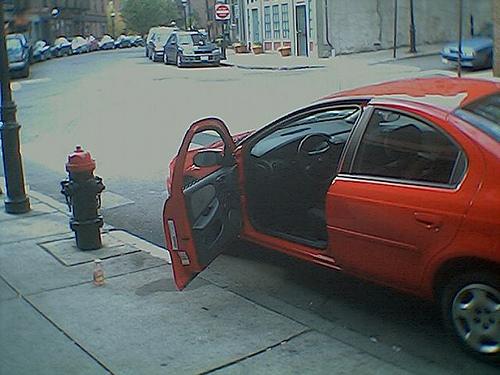Is one of the car's door open?
Be succinct. Yes. What color is the hydrant?
Give a very brief answer. Black. Is the car parked in a garage?
Quick response, please. No. Where is the car parked?
Concise answer only. Curb. 